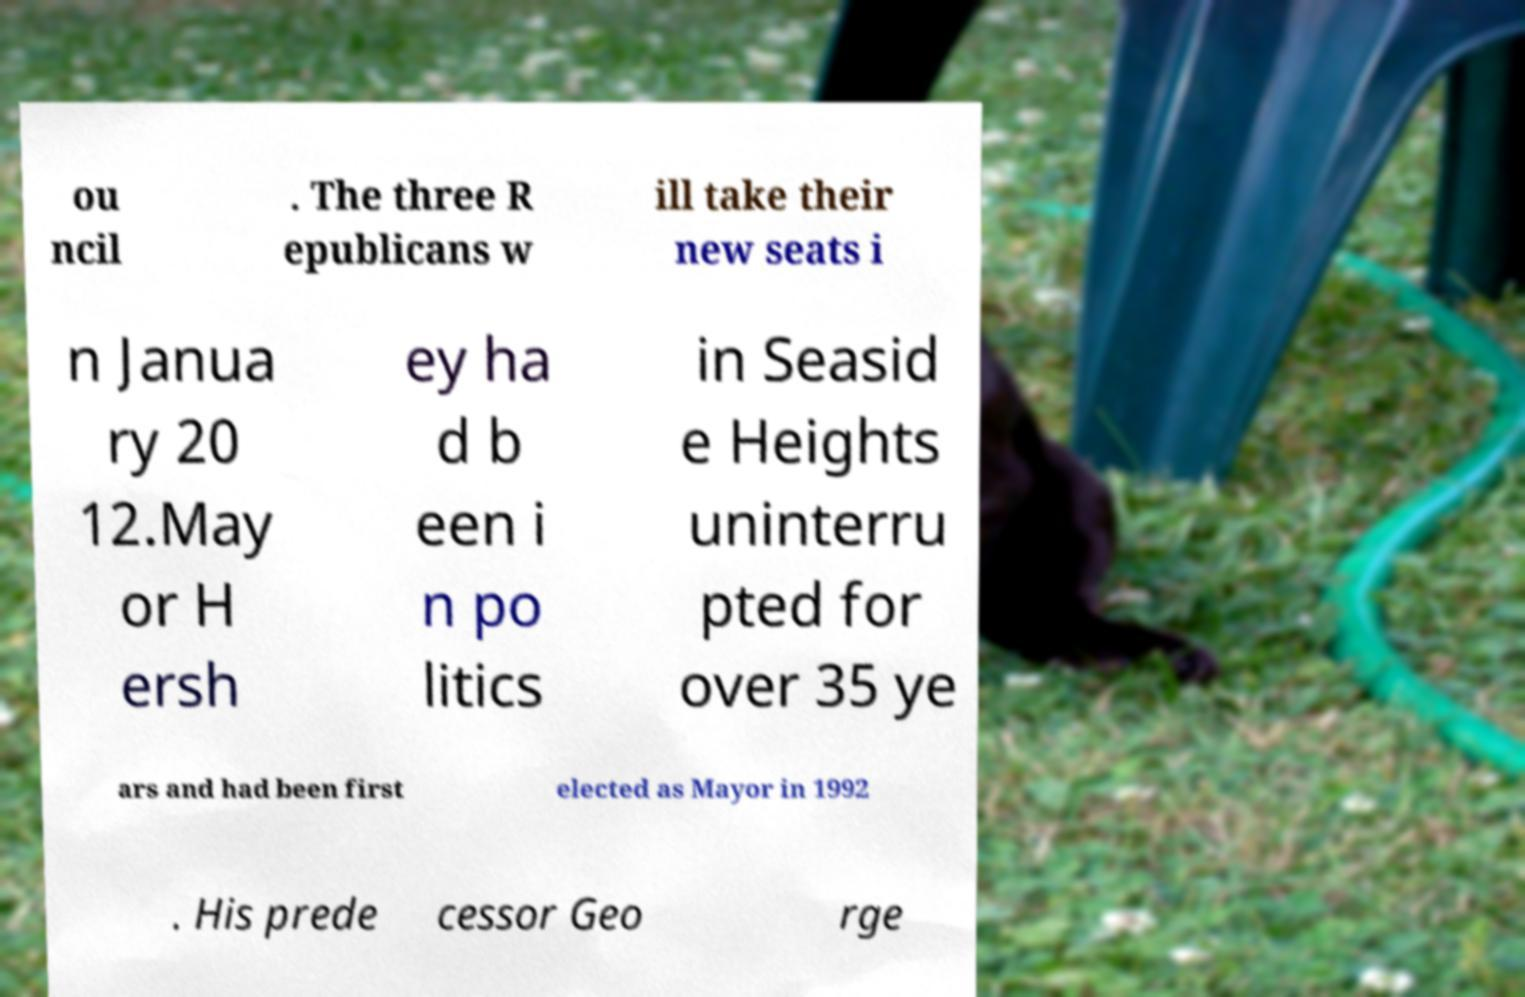Please read and relay the text visible in this image. What does it say? ou ncil . The three R epublicans w ill take their new seats i n Janua ry 20 12.May or H ersh ey ha d b een i n po litics in Seasid e Heights uninterru pted for over 35 ye ars and had been first elected as Mayor in 1992 . His prede cessor Geo rge 